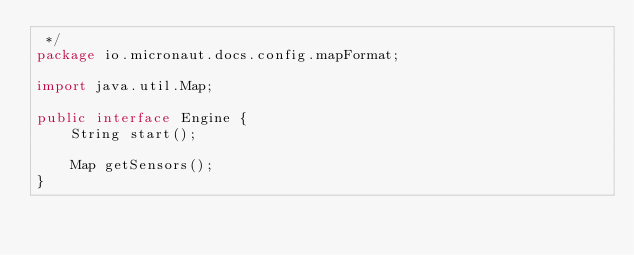Convert code to text. <code><loc_0><loc_0><loc_500><loc_500><_Java_> */
package io.micronaut.docs.config.mapFormat;

import java.util.Map;

public interface Engine {
    String start();

    Map getSensors();
}
</code> 